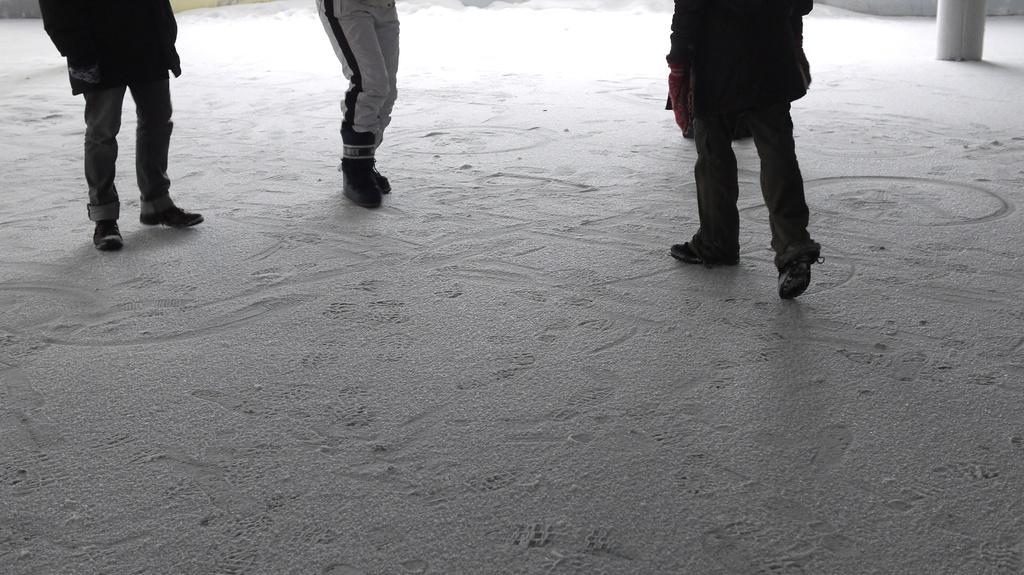Could you give a brief overview of what you see in this image? In this picture we can see the legs of the people. We can see the floor. On the right side of the picture we can see an object. 